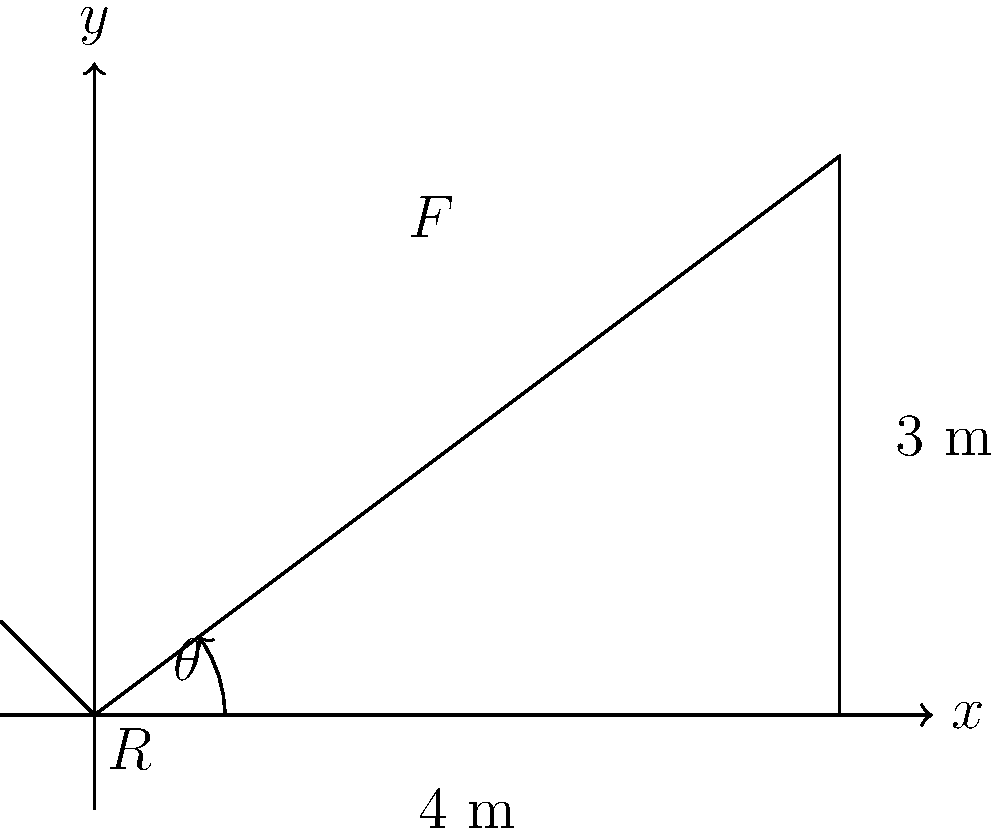As a Civil Engineering expert, consider the bridge support structure shown in the diagram. The support beam has a length of 5 meters and forms an angle $\theta$ with the horizontal. A force $F$ of 10 kN is applied at the top of the beam. What angle $\theta$ (in degrees) should the support beam make with the horizontal to minimize the reaction force $R$ at the base? Let's approach this step-by-step:

1) First, we need to understand that the reaction force $R$ will be minimized when it's perpendicular to the applied force $F$.

2) In this case, the optimal angle $\theta$ will make the support beam perpendicular to the force $F$.

3) We can determine this angle using the dimensions given in the diagram:
   - The horizontal distance is 4 m
   - The vertical distance is 3 m

4) We can use the arctangent function to find this angle:

   $$\theta = \arctan(\frac{3}{4})$$

5) To convert this to degrees, we multiply by $\frac{180}{\pi}$:

   $$\theta = \arctan(\frac{3}{4}) \cdot \frac{180}{\pi}$$

6) Calculating this:
   $$\theta \approx 36.87°$$

Therefore, the support beam should make an angle of approximately 36.87° with the horizontal to minimize the reaction force at the base.
Answer: 36.87° 